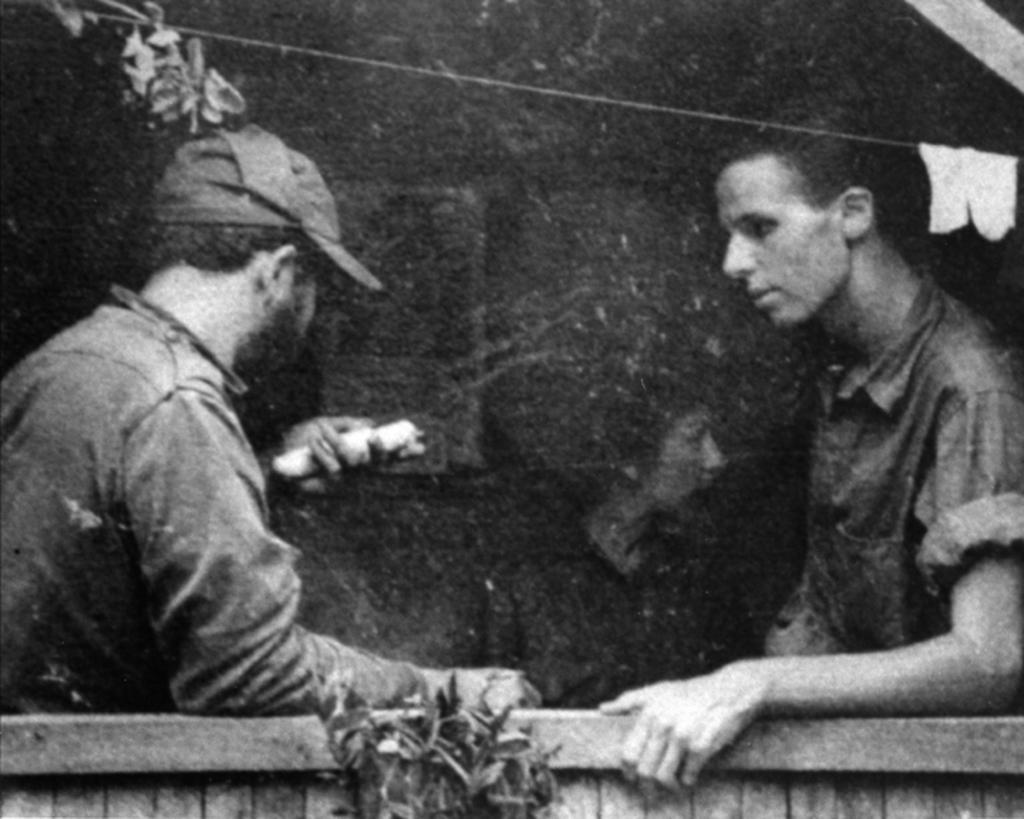How many people are in the image? There are two persons in the image. What is one of the persons wearing? One of the persons is wearing a shirt. What color is the background of the image? The background of the image is black. What type of soup is being served in the image? There is no soup present in the image. How many units of lipstick can be seen in the image? There is no lipstick present in the image. 